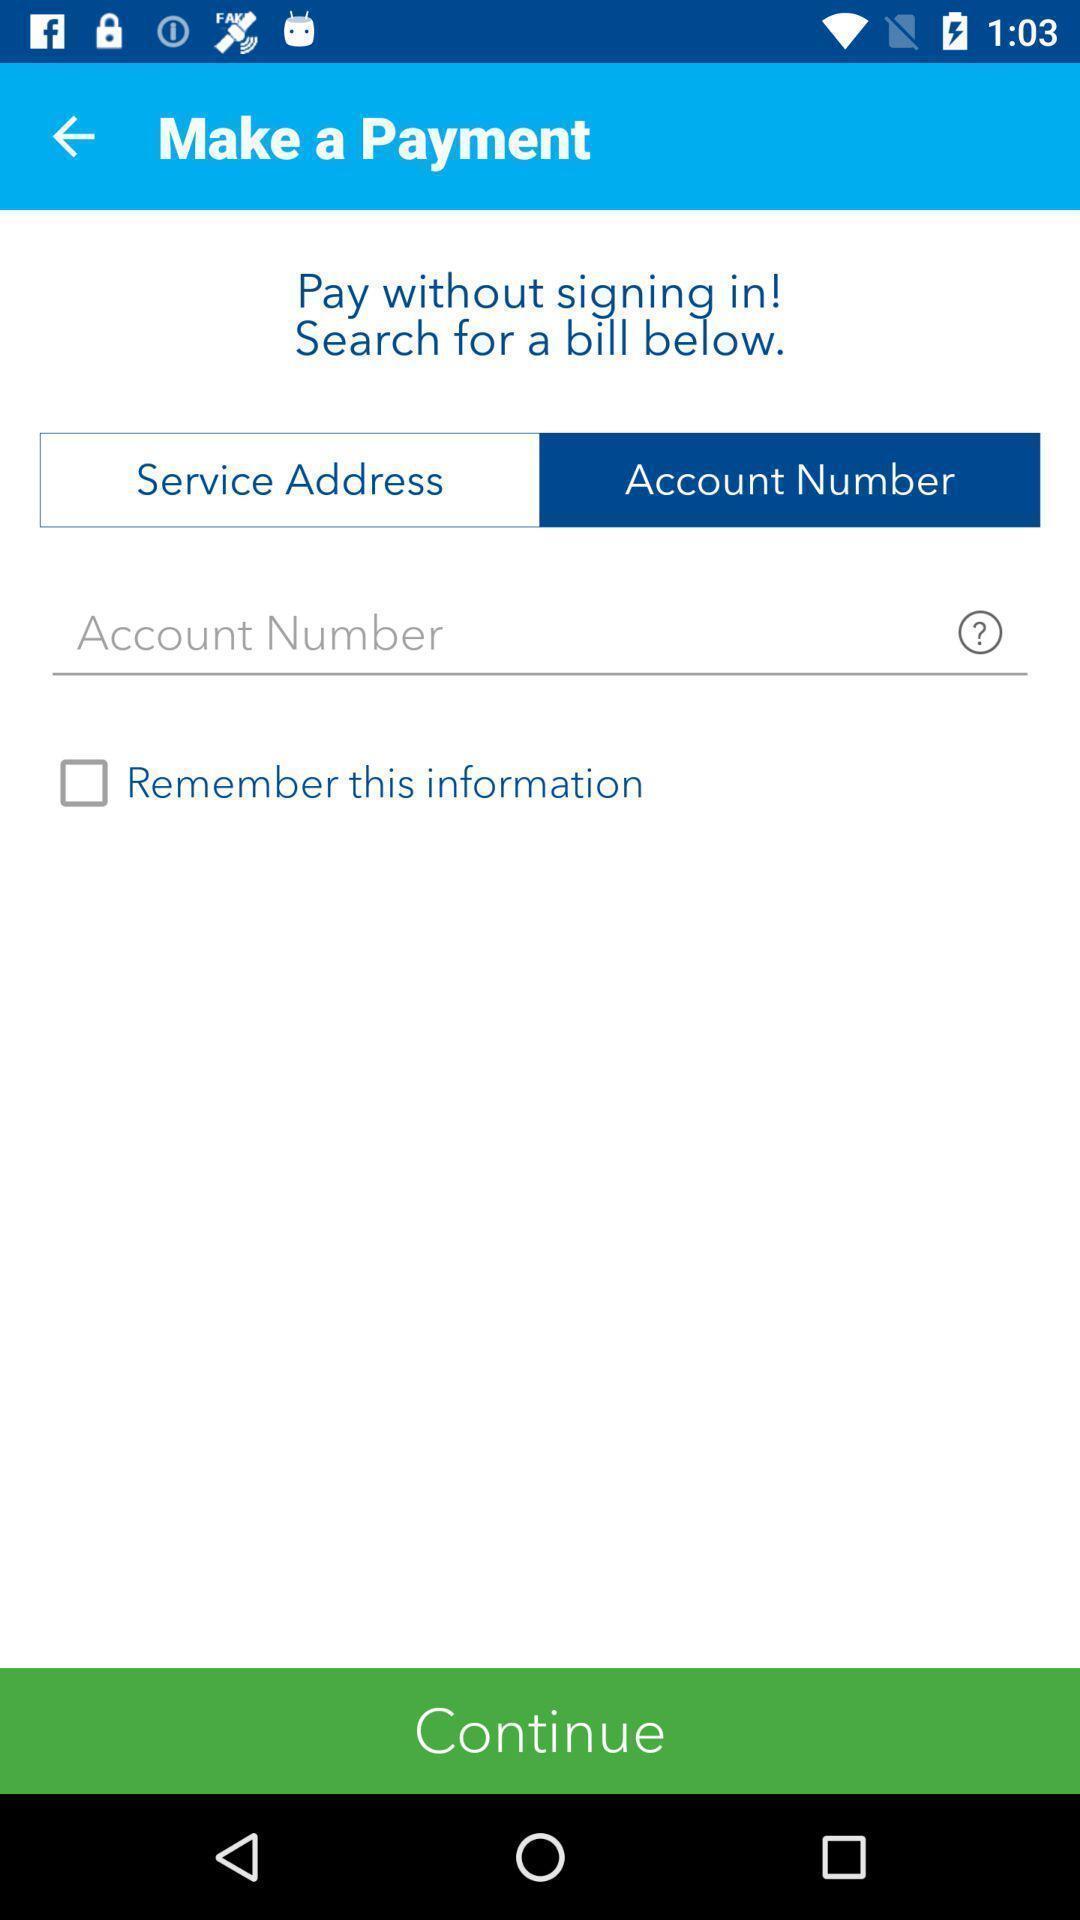Summarize the information in this screenshot. Payment website asking for account number. 